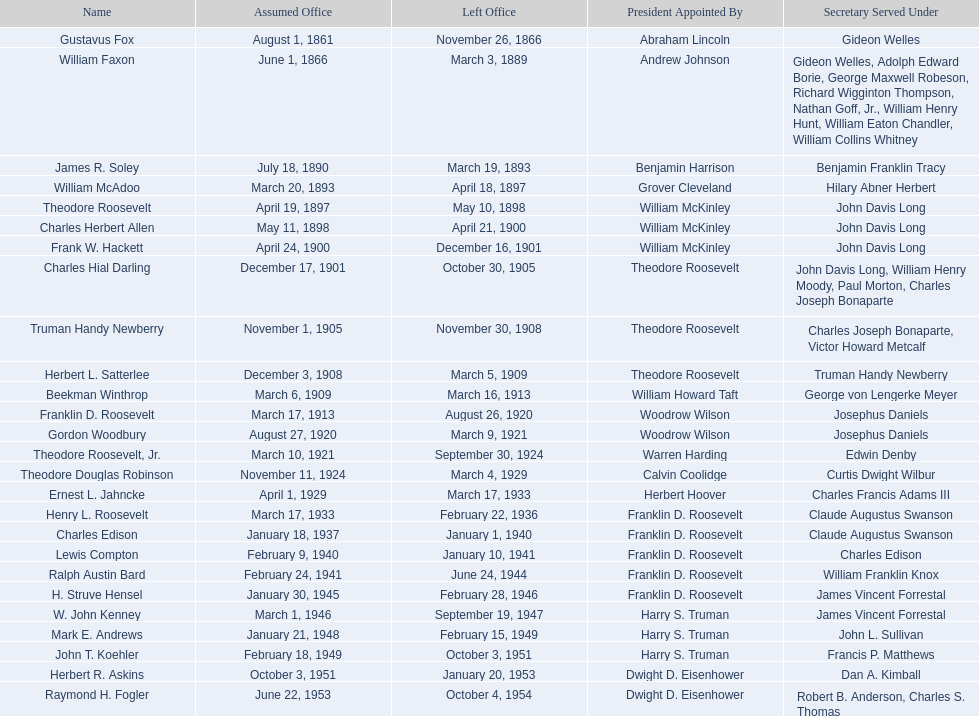When did raymond h. fogler leave the office of assistant secretary of the navy? October 4, 1954. 